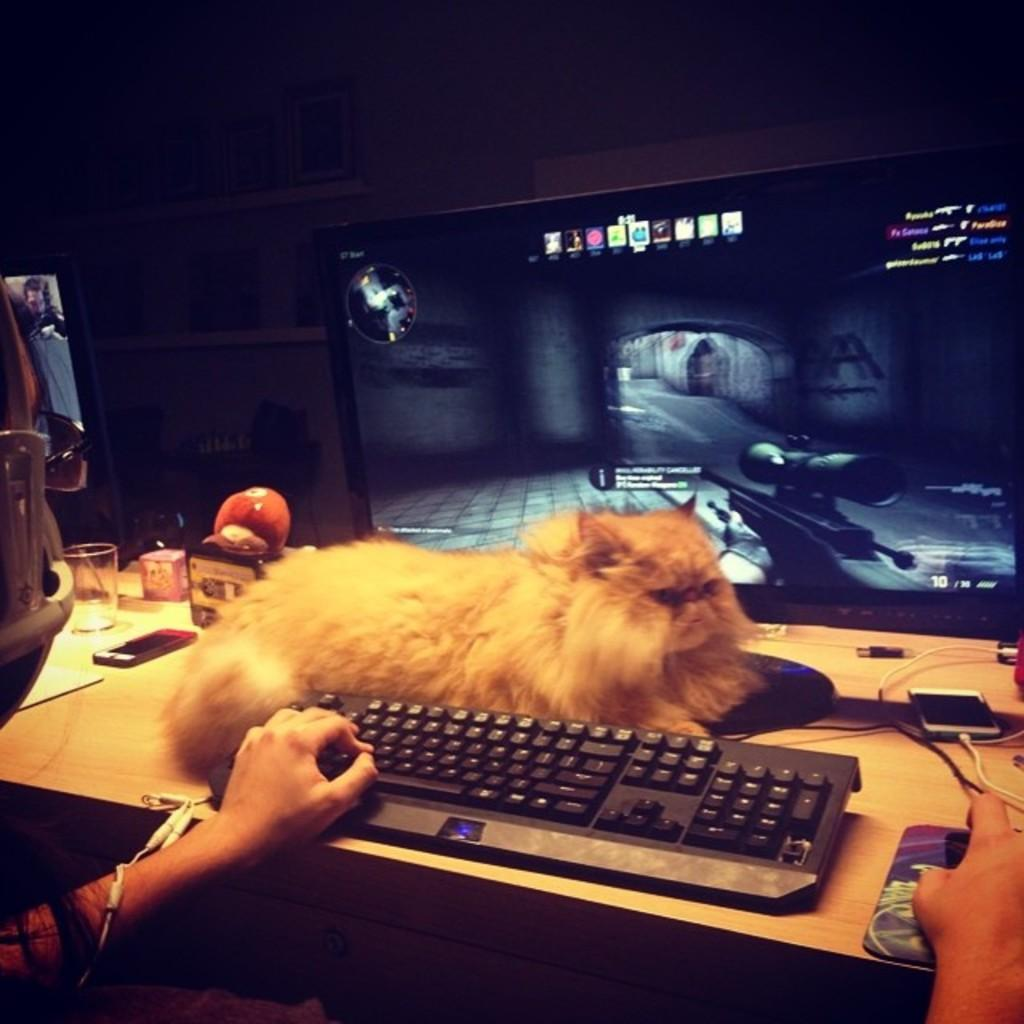What part of a person can be seen in the image? There is a person's hand in the image. What device is the person using? There is a keyboard in the image. What animal is present in the image? There is a cat in the image. What electronic device is visible in the image? There is a monitor in the image. What type of communication devices are present in the image? There are mobile phones in the image. What beverage container is visible in the image? There is a glass in the image. What other objects can be seen on the table in the image? There are additional objects on the table. What is the lighting condition in the image? The background of the image is dark. How does the person's hand affect the temper of the sponge in the image? There is no sponge present in the image, so the person's hand does not affect its temper. What type of journey is the person taking in the image? There is no indication of a journey in the image; it shows a person's hand using a keyboard. 